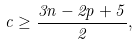Convert formula to latex. <formula><loc_0><loc_0><loc_500><loc_500>c \geq \frac { 3 n - 2 p + 5 } { 2 } ,</formula> 